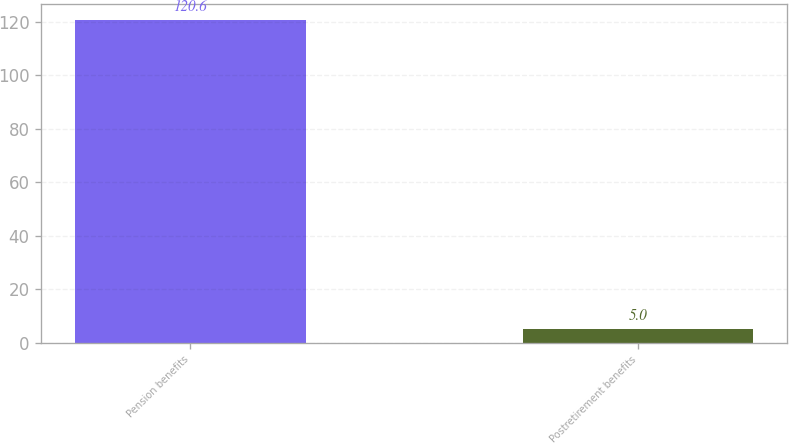Convert chart to OTSL. <chart><loc_0><loc_0><loc_500><loc_500><bar_chart><fcel>Pension benefits<fcel>Postretirement benefits<nl><fcel>120.6<fcel>5<nl></chart> 